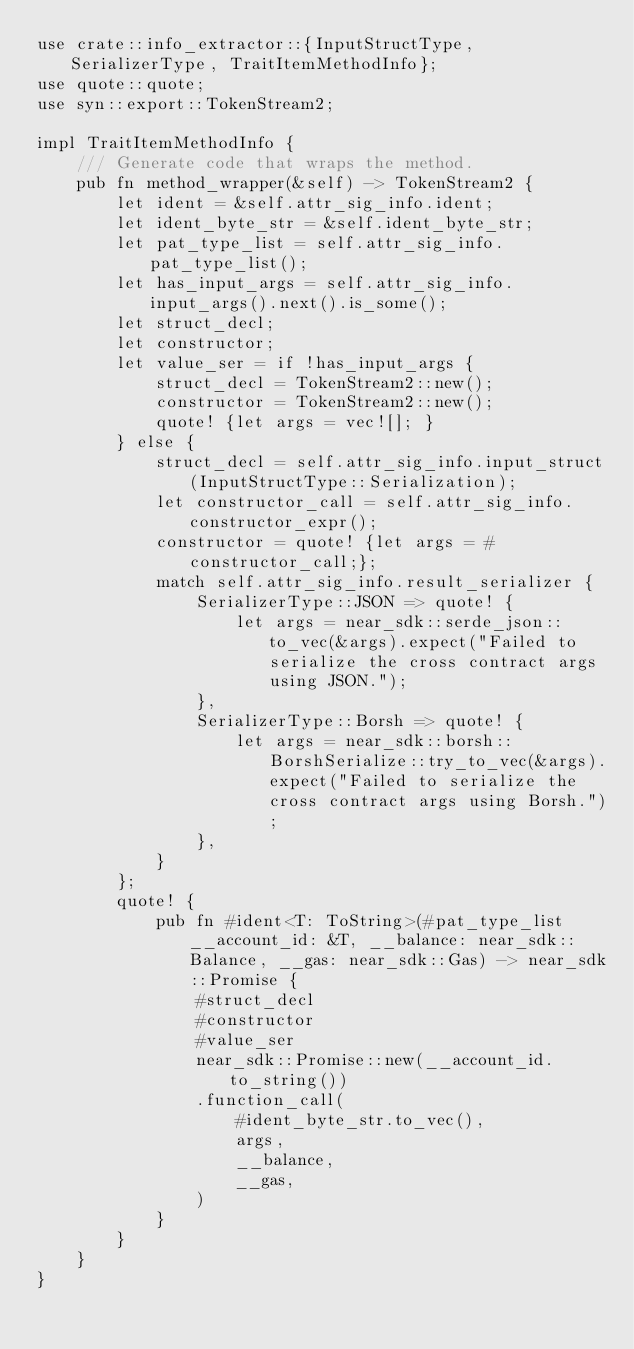Convert code to text. <code><loc_0><loc_0><loc_500><loc_500><_Rust_>use crate::info_extractor::{InputStructType, SerializerType, TraitItemMethodInfo};
use quote::quote;
use syn::export::TokenStream2;

impl TraitItemMethodInfo {
    /// Generate code that wraps the method.
    pub fn method_wrapper(&self) -> TokenStream2 {
        let ident = &self.attr_sig_info.ident;
        let ident_byte_str = &self.ident_byte_str;
        let pat_type_list = self.attr_sig_info.pat_type_list();
        let has_input_args = self.attr_sig_info.input_args().next().is_some();
        let struct_decl;
        let constructor;
        let value_ser = if !has_input_args {
            struct_decl = TokenStream2::new();
            constructor = TokenStream2::new();
            quote! {let args = vec![]; }
        } else {
            struct_decl = self.attr_sig_info.input_struct(InputStructType::Serialization);
            let constructor_call = self.attr_sig_info.constructor_expr();
            constructor = quote! {let args = #constructor_call;};
            match self.attr_sig_info.result_serializer {
                SerializerType::JSON => quote! {
                    let args = near_sdk::serde_json::to_vec(&args).expect("Failed to serialize the cross contract args using JSON.");
                },
                SerializerType::Borsh => quote! {
                    let args = near_sdk::borsh::BorshSerialize::try_to_vec(&args).expect("Failed to serialize the cross contract args using Borsh.");
                },
            }
        };
        quote! {
            pub fn #ident<T: ToString>(#pat_type_list __account_id: &T, __balance: near_sdk::Balance, __gas: near_sdk::Gas) -> near_sdk::Promise {
                #struct_decl
                #constructor
                #value_ser
                near_sdk::Promise::new(__account_id.to_string())
                .function_call(
                    #ident_byte_str.to_vec(),
                    args,
                    __balance,
                    __gas,
                )
            }
        }
    }
}
</code> 